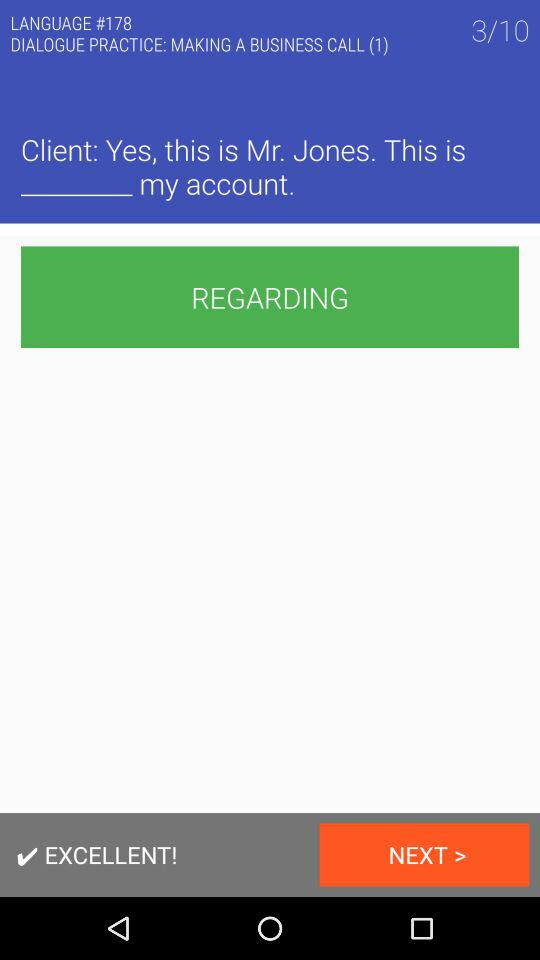What name is given on the screen? The given name is Mr. Jones. 